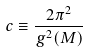Convert formula to latex. <formula><loc_0><loc_0><loc_500><loc_500>c \equiv \frac { 2 \pi ^ { 2 } } { g ^ { 2 } ( M ) }</formula> 